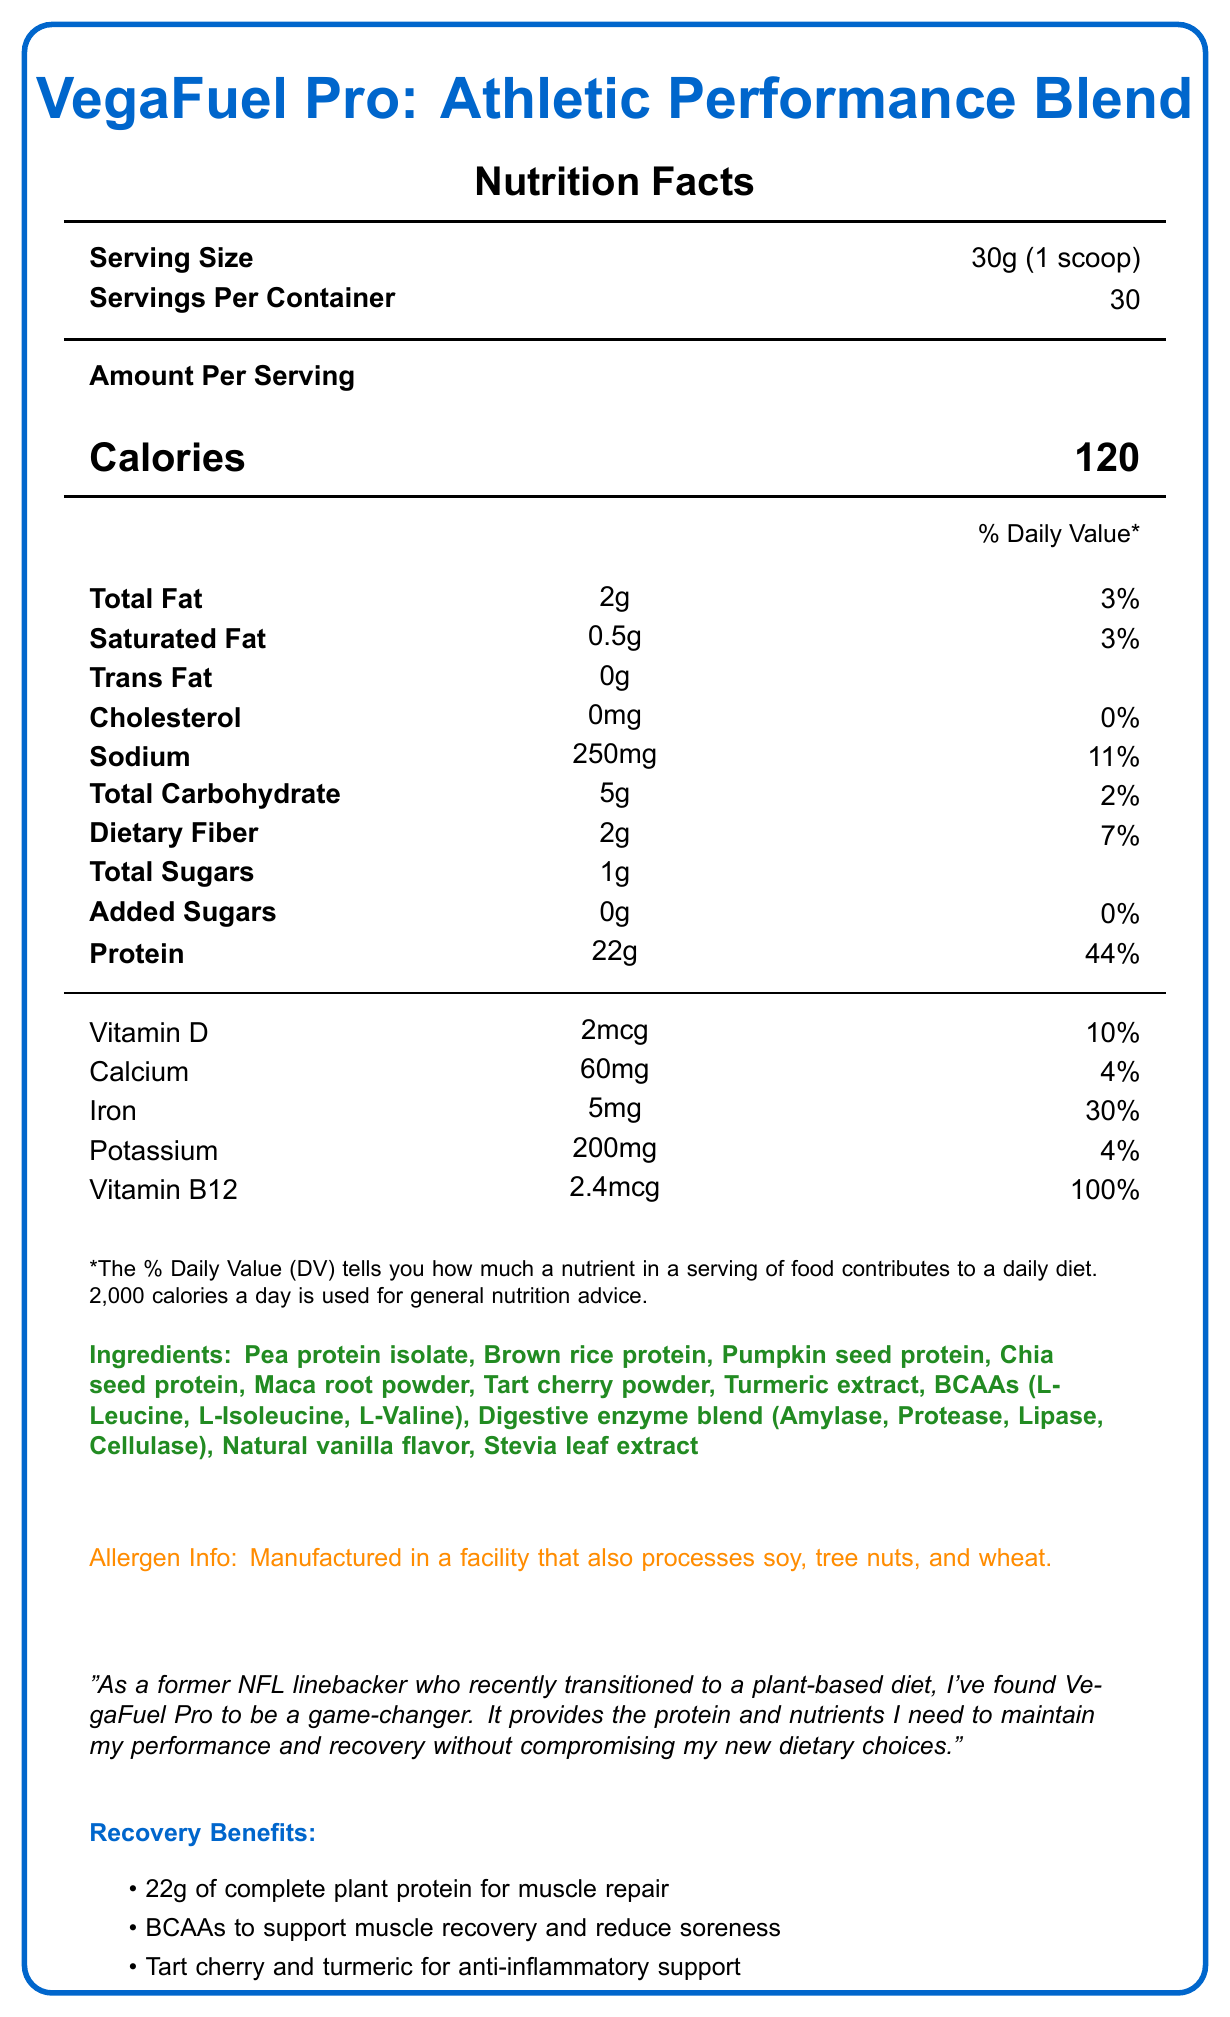What is the serving size for VegaFuel Pro? The serving size is listed at the top of the Nutrition Facts label as 30g, which corresponds to 1 scoop.
Answer: 30g (1 scoop) How many calories are there per serving of VegaFuel Pro? The document specifies that each serving contains 120 calories.
Answer: 120 calories How much protein does one serving of VegaFuel Pro provide? The amount of protein per serving is listed as 22g under the Nutrition Facts.
Answer: 22g What is the percentage of the Daily Value for Vitamin B12 per serving? The document states that each serving of VegaFuel Pro provides 100% of the Daily Value for Vitamin B12.
Answer: 100% What are the main sources of protein in VegaFuel Pro? These ingredients are clearly listed under the “Ingredients” section.
Answer: Pea protein isolate, Brown rice protein, Pumpkin seed protein, Chia seed protein Which of the following nutrients has the highest daily value percentage per serving of VegaFuel Pro? A. Vitamin D B. Iron C. Sodium D. Protein Protein has the highest daily value percentage per serving at 44%, followed by Iron at 30%.
Answer: D. Protein How many grams of dietary fiber are in each serving of VegaFuel Pro? The amount of dietary fiber is listed as 2g per serving.
Answer: 2g Does VegaFuel Pro contain any trans fat? The label indicates that the amount of trans fat is 0g.
Answer: No How many grams of added sugars are in a serving of VegaFuel Pro? The nutrition facts state that the amount of added sugars per serving is 0g.
Answer: 0g Which of the following is a performance enhancer in VegaFuel Pro? i. Tart cherry powder ii. Digestive enzyme blend iii. Maca root powder iv. Turmeric extract Maca root is listed among the performance enhancers, whereas tart cherry and turmeric are cited for recovery benefits.
Answer: iii. Maca root powder Is VegaFuel Pro suitable for someone with a soy allergy? The allergen info indicates that it is manufactured in a facility that also processes soy, tree nuts, and wheat.
Answer: No Which ingredients in VegaFuel Pro support anti-inflammatory benefits? The recovery benefits section lists tart cherry and turmeric for anti-inflammatory support.
Answer: Tart cherry and turmeric Describe the main idea of VegaFuel Pro's Nutrition Facts Label. The document outlines the nutritional content, serving size, number of servings, and ingredients of VegaFuel Pro. It particularly highlights its benefits for athletes, including muscle recovery and anti-inflammatory properties.
Answer: VegaFuel Pro is a plant-based protein powder designed for athletes, providing significant amounts of protein, essential vitamins, and performance enhancers. It contains 22g of protein per serving along with various vitamins and minerals, and it includes ingredients aimed at muscle recovery and inflammation reduction. It is manufactured in a facility that processes common allergens. Does VegaFuel Pro help prevent Vitamin B12 deficiency common in vegan diets? The label states that the product provides 100% of the Daily Value for Vitamin B12, which is commonly deficient in vegan diets.
Answer: Yes How old was the athlete who provided the testimonial? The document contains a testimonial from a former NFL linebacker but does not provide the athlete's age.
Answer: Not enough information 